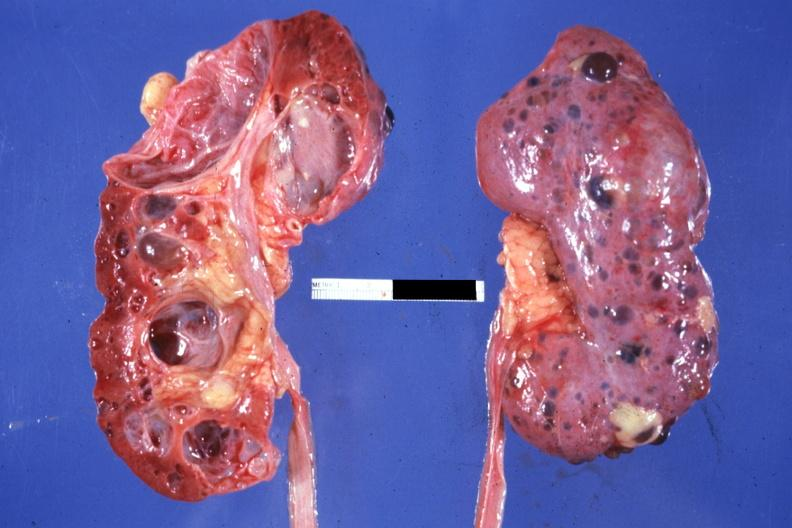s nice photo one kidney opened the other from capsular surface many cysts?
Answer the question using a single word or phrase. Yes 